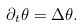Convert formula to latex. <formula><loc_0><loc_0><loc_500><loc_500>\partial _ { t } \theta = \Delta \theta .</formula> 